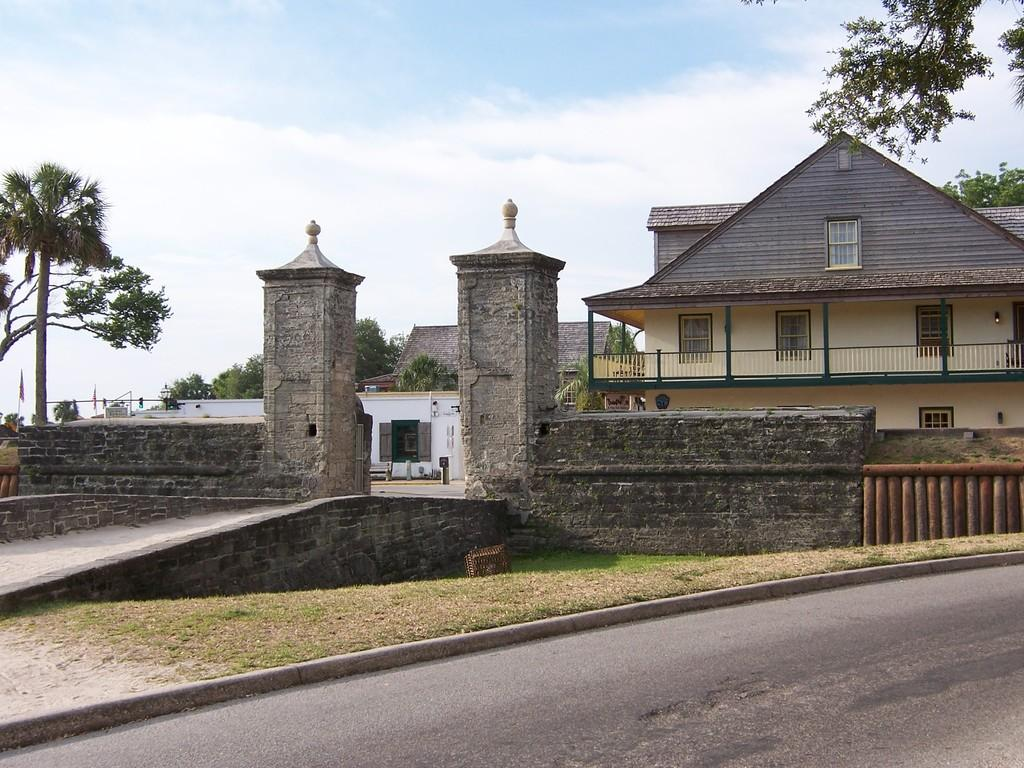What is located in the foreground of the image? There is a road and a compound wall of a house in the foreground of the image. What can be seen in the background of the image? There are houses, trees, and a sunny sky visible in the background of the image. What is the price of the giraffe in the image? There is no giraffe present in the image, so it is not possible to determine its price. Can you tell me the name of the uncle in the image? There is no person or reference to an uncle in the image. 